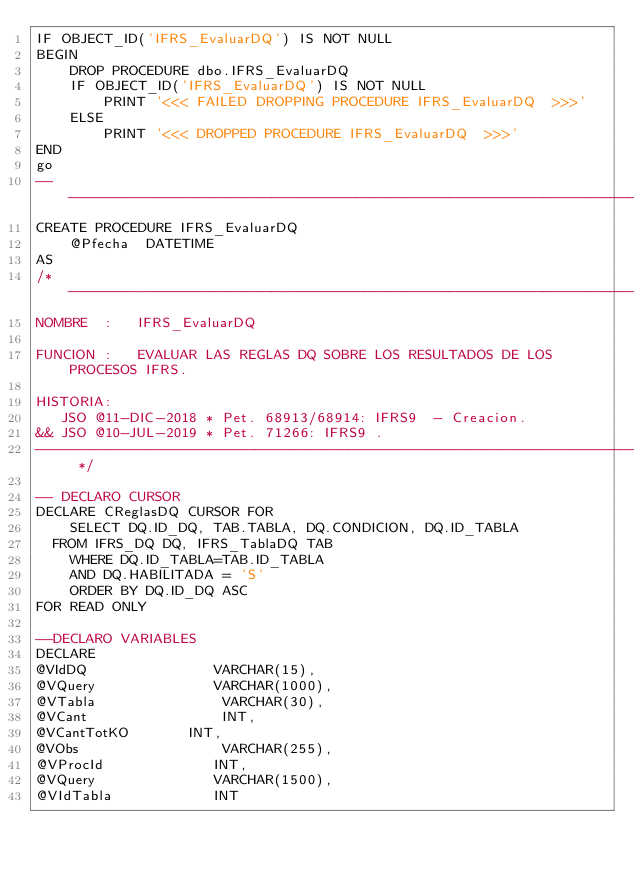<code> <loc_0><loc_0><loc_500><loc_500><_SQL_>IF OBJECT_ID('IFRS_EvaluarDQ') IS NOT NULL
BEGIN
    DROP PROCEDURE dbo.IFRS_EvaluarDQ 
    IF OBJECT_ID('IFRS_EvaluarDQ') IS NOT NULL
        PRINT '<<< FAILED DROPPING PROCEDURE IFRS_EvaluarDQ  >>>'
    ELSE
        PRINT '<<< DROPPED PROCEDURE IFRS_EvaluarDQ  >>>'
END
go
-----------------------------------------------------------------------------------------------------
CREATE PROCEDURE IFRS_EvaluarDQ
    @Pfecha  DATETIME 
AS
/* -------------------------------------------------------------------------------------------------
NOMBRE  :   IFRS_EvaluarDQ 

FUNCION :   EVALUAR LAS REGLAS DQ SOBRE LOS RESULTADOS DE LOS PROCESOS IFRS.

HISTORIA:
	 JSO @11-DIC-2018 * Pet. 68913/68914: IFRS9  - Creacion.  
&& JSO @10-JUL-2019 * Pet. 71266: IFRS9 .   
------------------------------------------------------------------------------------------------- */

-- DECLARO CURSOR
DECLARE CReglasDQ CURSOR FOR
    SELECT DQ.ID_DQ, TAB.TABLA, DQ.CONDICION, DQ.ID_TABLA 
	FROM IFRS_DQ DQ, IFRS_TablaDQ TAB
    WHERE DQ.ID_TABLA=TAB.ID_TABLA
    AND DQ.HABILITADA = 'S'
    ORDER BY DQ.ID_DQ ASC
FOR READ ONLY

--DECLARO VARIABLES
DECLARE
@VIdDQ               VARCHAR(15),
@VQuery          	   VARCHAR(1000),
@VTabla               VARCHAR(30),
@VCant                INT,
@VCantTotKO       INT,
@VObs                 VARCHAR(255),
@VProcId             INT,
@VQuery              VARCHAR(1500),
@VIdTabla            INT
</code> 